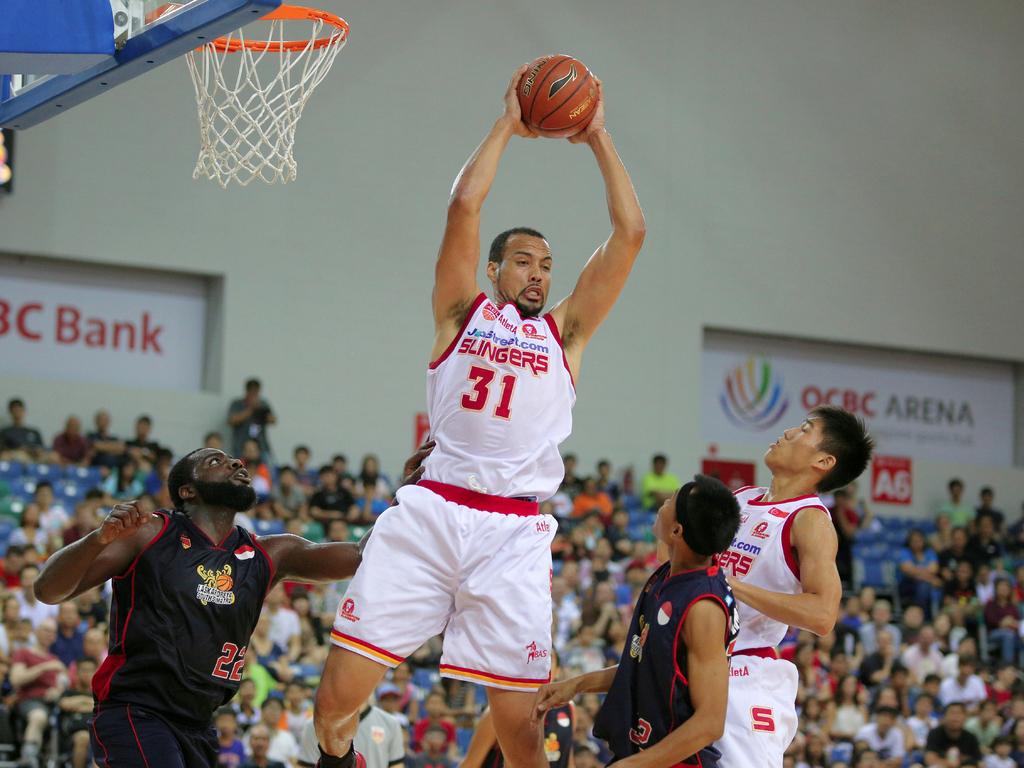What number player has the ball?
Provide a short and direct response. 31. What is the team of the man with the ball?
Your answer should be very brief. Slingers. 